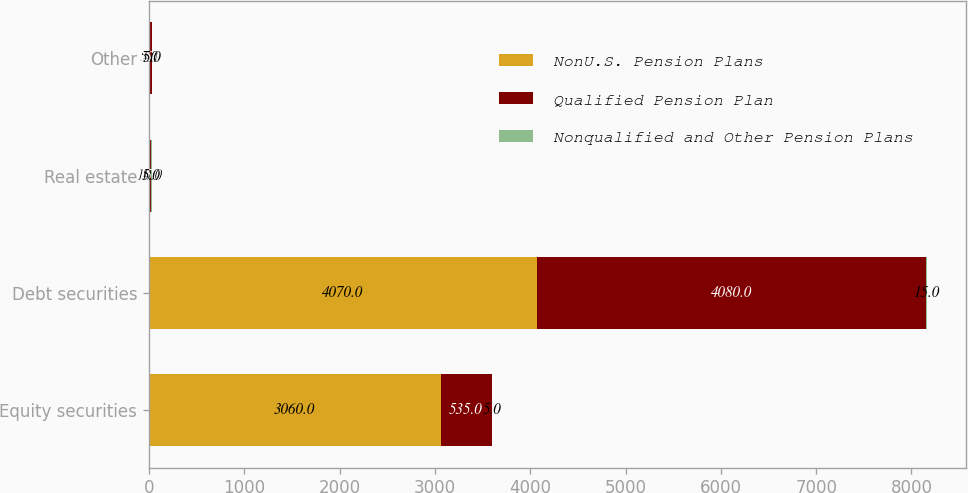<chart> <loc_0><loc_0><loc_500><loc_500><stacked_bar_chart><ecel><fcel>Equity securities<fcel>Debt securities<fcel>Real estate<fcel>Other<nl><fcel>NonU.S. Pension Plans<fcel>3060<fcel>4070<fcel>10<fcel>5<nl><fcel>Qualified Pension Plan<fcel>535<fcel>4080<fcel>15<fcel>25<nl><fcel>Nonqualified and Other Pension Plans<fcel>5<fcel>15<fcel>5<fcel>5<nl></chart> 